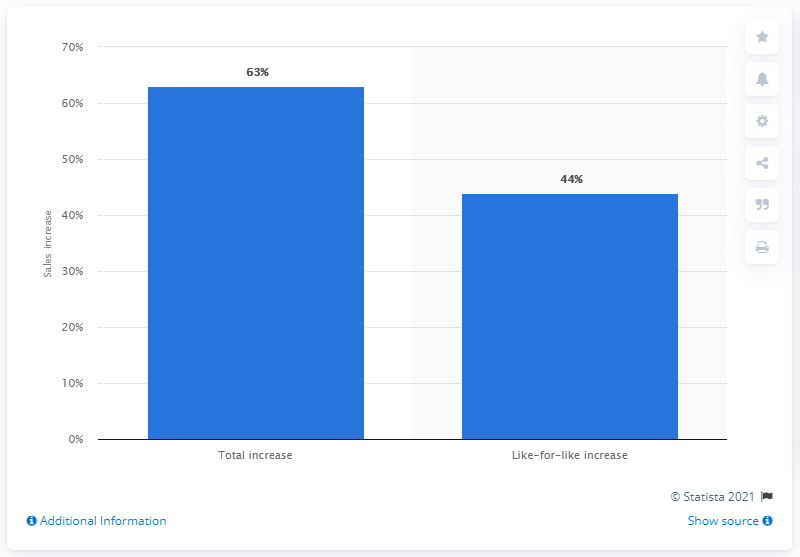Give some essential details in this illustration. During the COVID-19 pandemic, like-for-like game sales increased by 44%. 